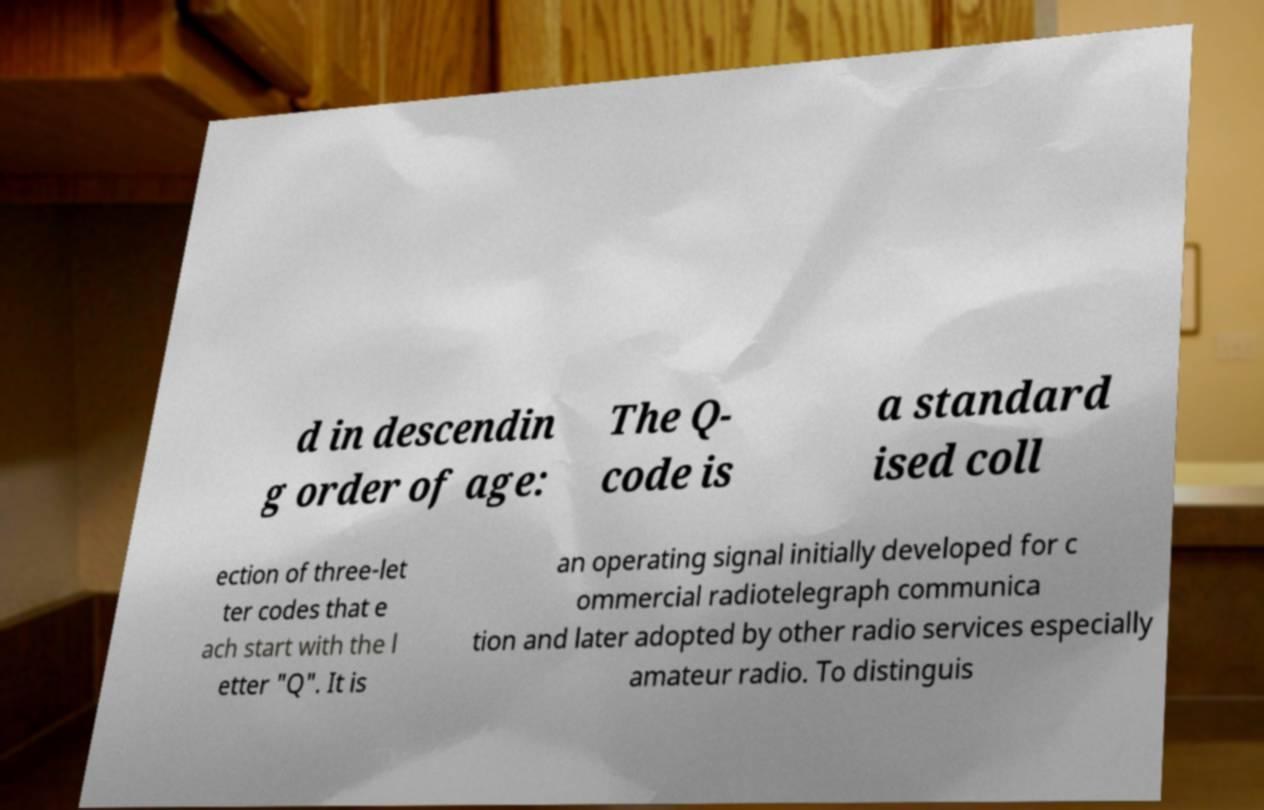Could you extract and type out the text from this image? d in descendin g order of age: The Q- code is a standard ised coll ection of three-let ter codes that e ach start with the l etter "Q". It is an operating signal initially developed for c ommercial radiotelegraph communica tion and later adopted by other radio services especially amateur radio. To distinguis 